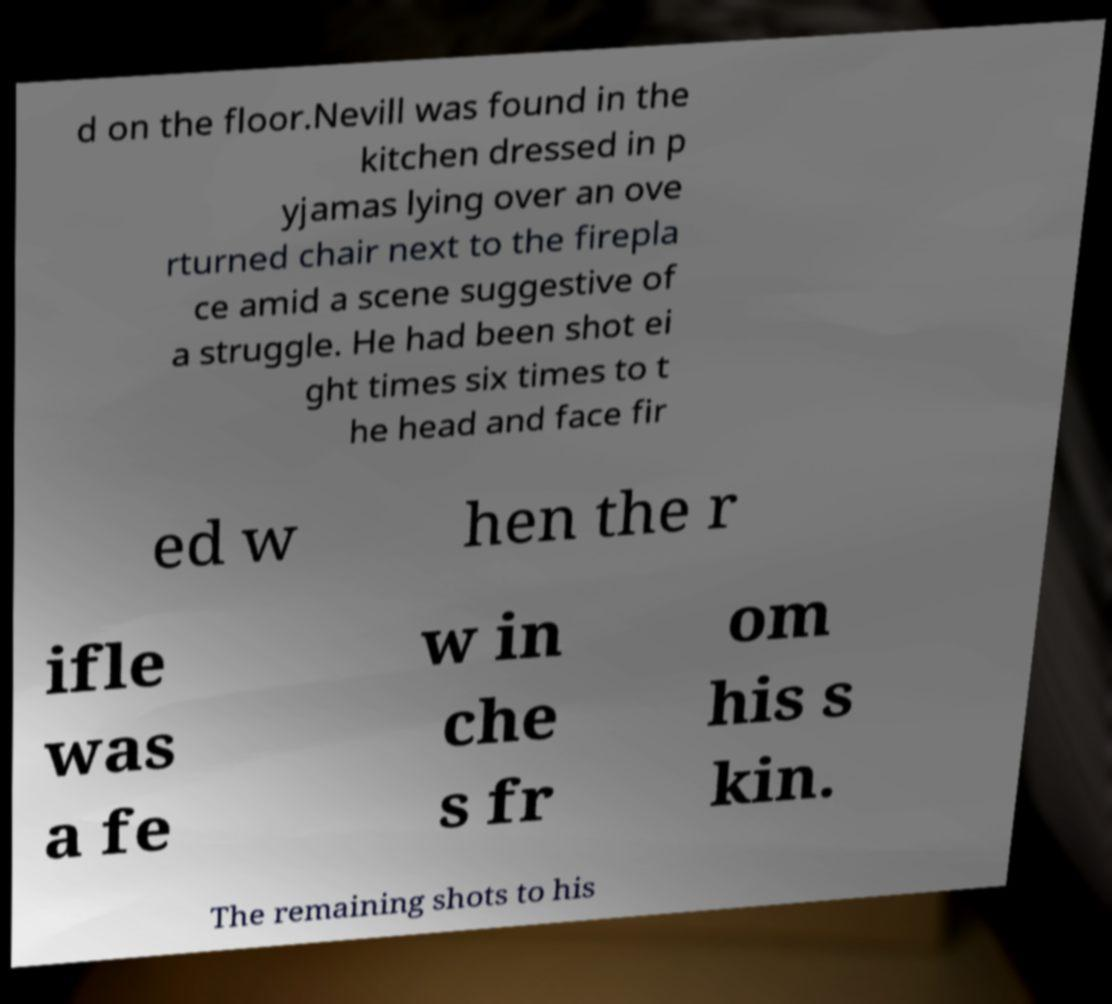Can you accurately transcribe the text from the provided image for me? d on the floor.Nevill was found in the kitchen dressed in p yjamas lying over an ove rturned chair next to the firepla ce amid a scene suggestive of a struggle. He had been shot ei ght times six times to t he head and face fir ed w hen the r ifle was a fe w in che s fr om his s kin. The remaining shots to his 